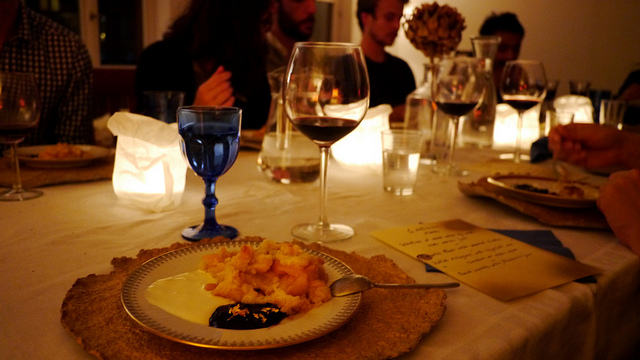<image>Is this meal sweet? I am not sure if the meal is sweet. It can be both sweet and not sweet. Is this meal sweet? I don't know if this meal is sweet. It can be both sweet and not sweet. 